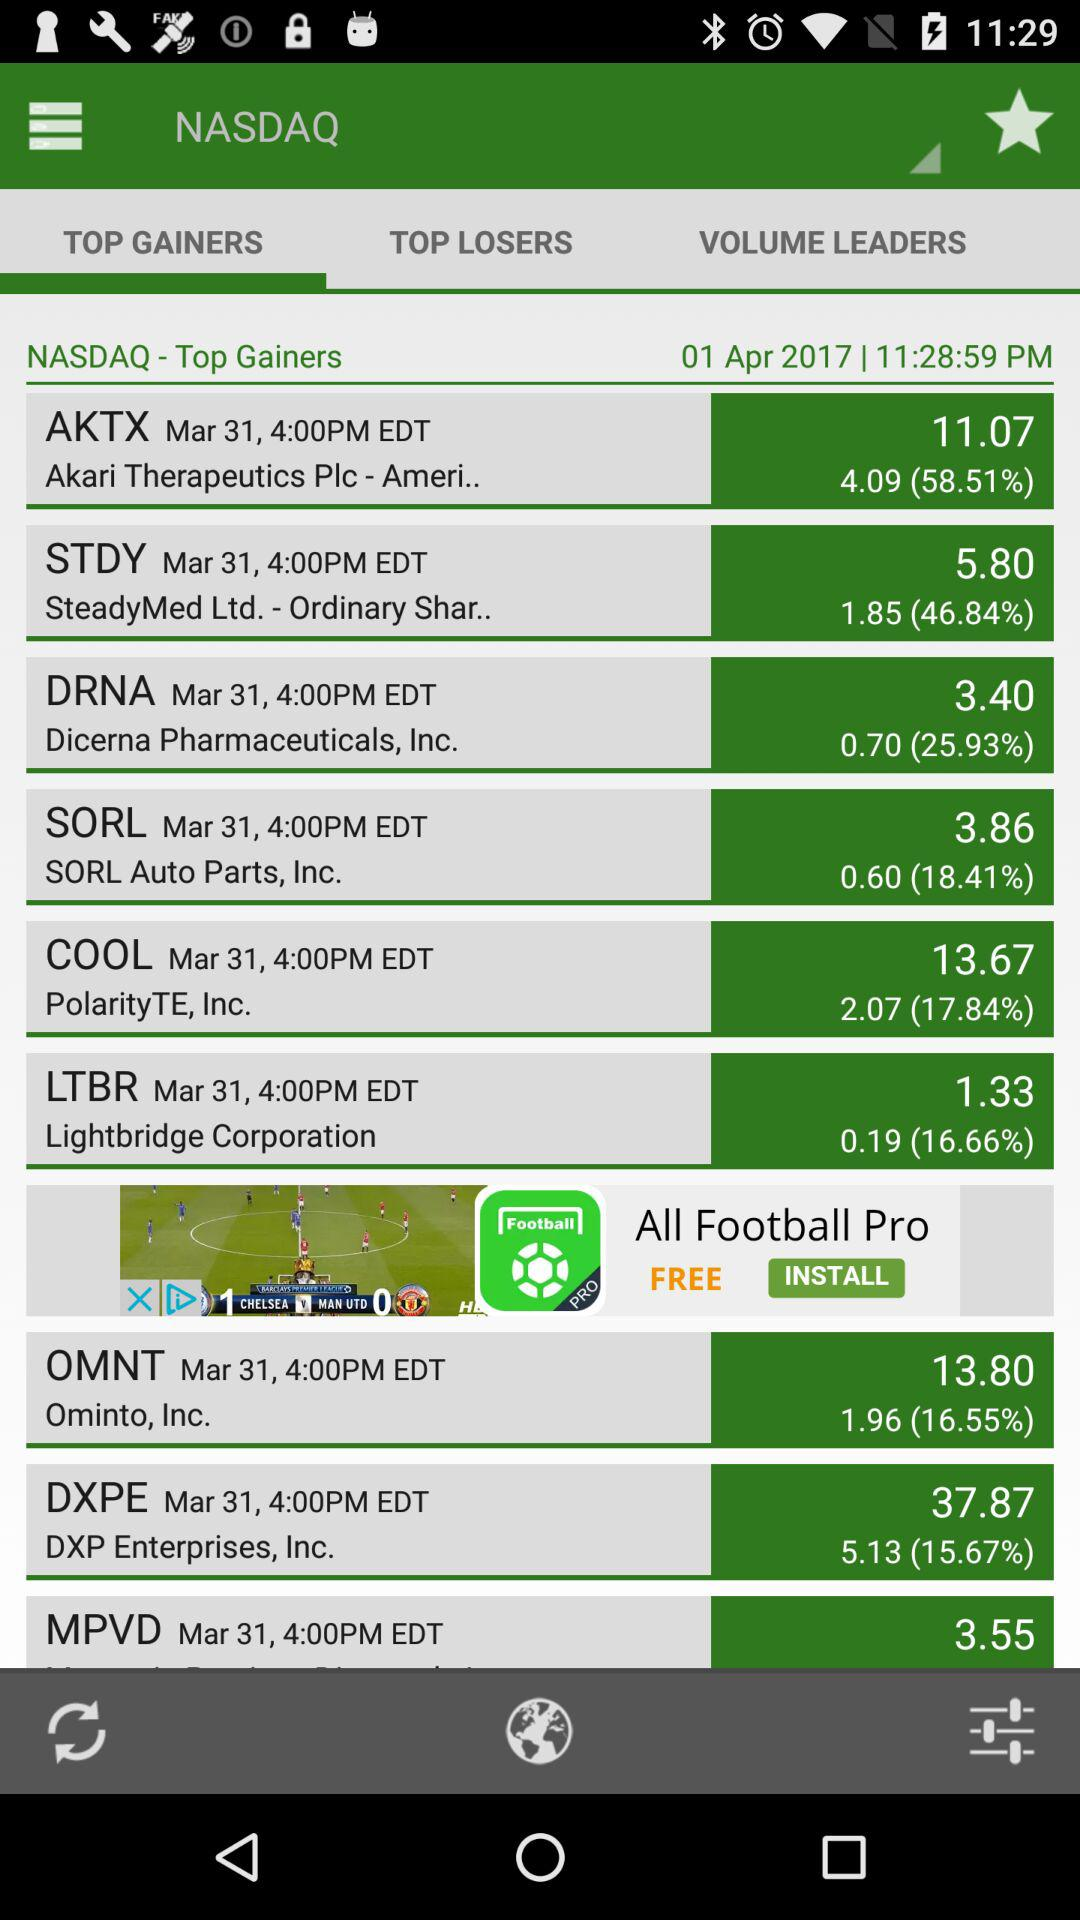Which stock has the highest percentage change?
Answer the question using a single word or phrase. AKTX 